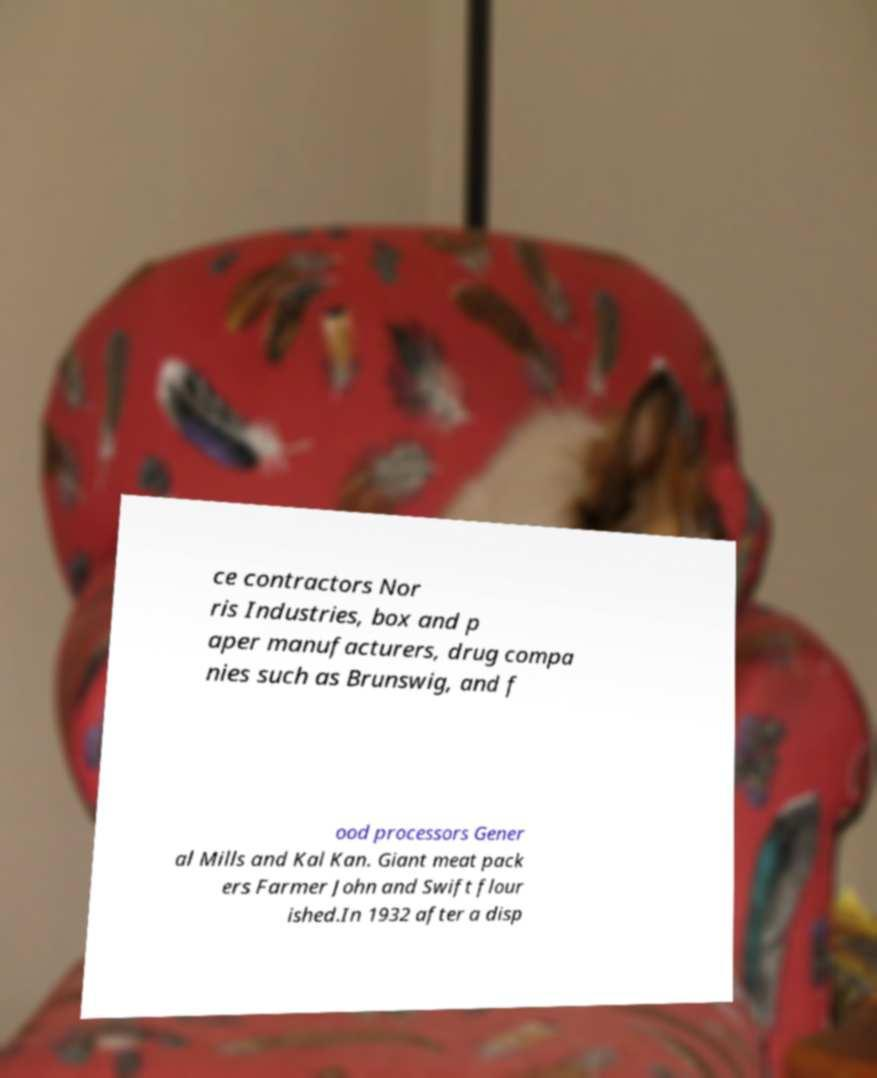I need the written content from this picture converted into text. Can you do that? ce contractors Nor ris Industries, box and p aper manufacturers, drug compa nies such as Brunswig, and f ood processors Gener al Mills and Kal Kan. Giant meat pack ers Farmer John and Swift flour ished.In 1932 after a disp 